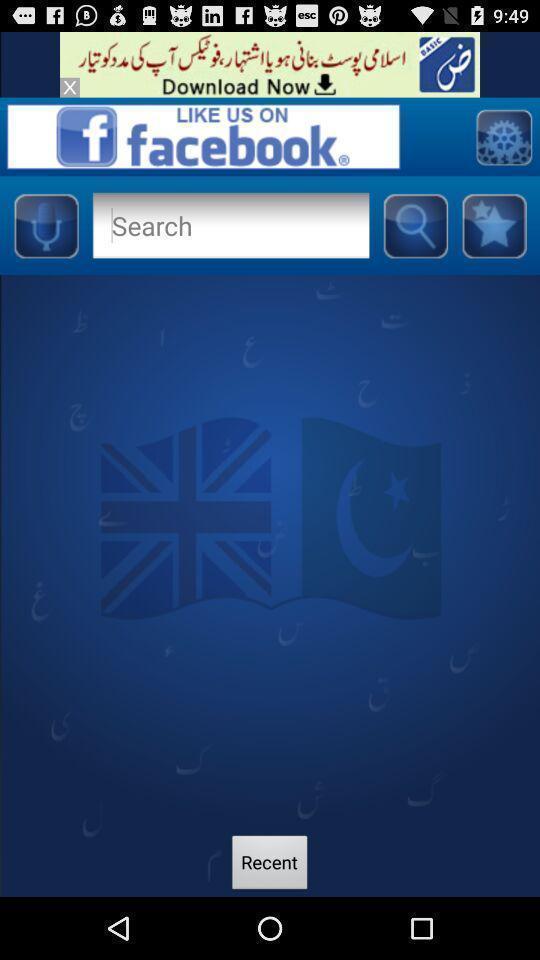Describe the visual elements of this screenshot. Search page. 